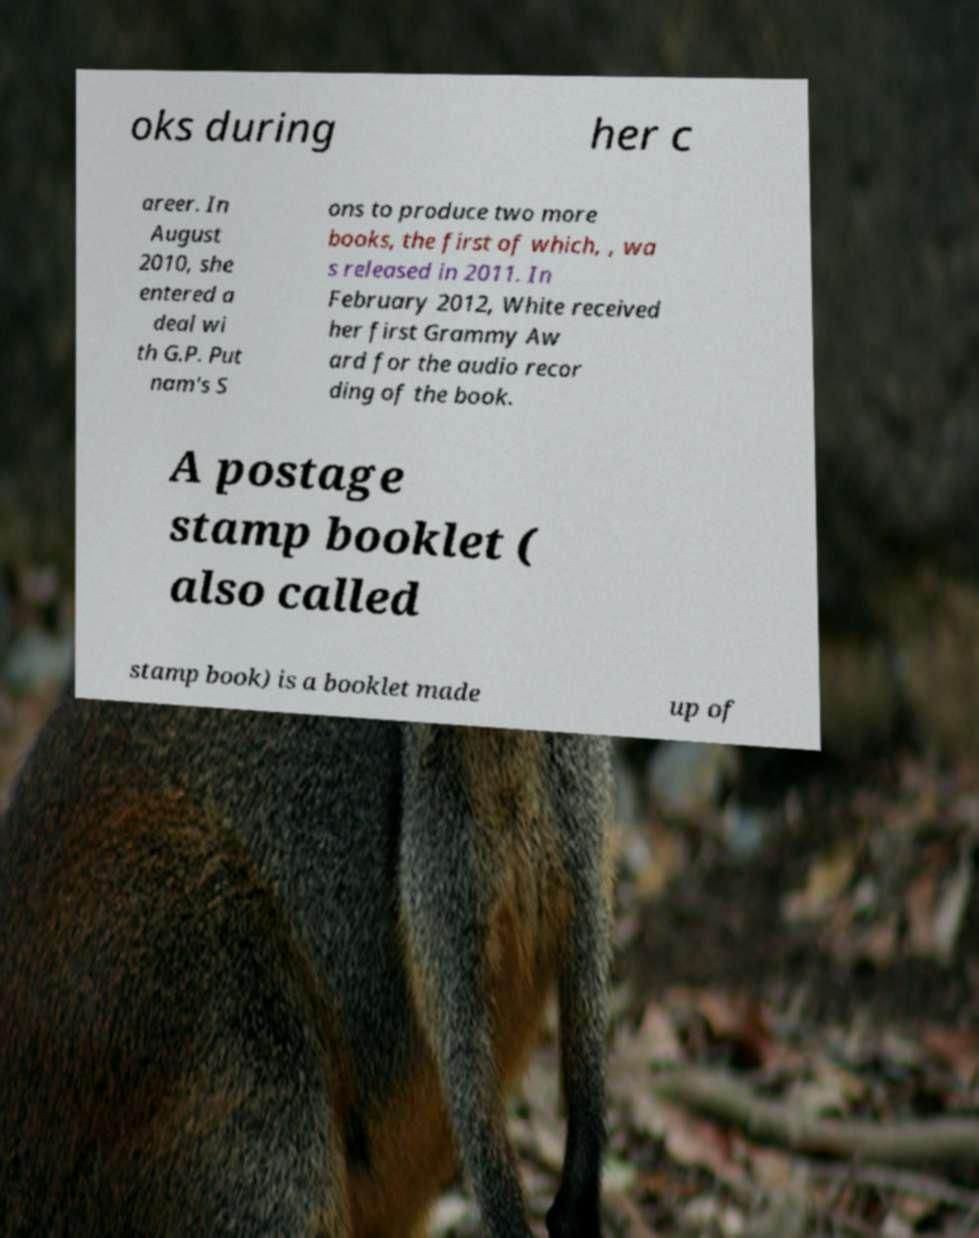What messages or text are displayed in this image? I need them in a readable, typed format. oks during her c areer. In August 2010, she entered a deal wi th G.P. Put nam's S ons to produce two more books, the first of which, , wa s released in 2011. In February 2012, White received her first Grammy Aw ard for the audio recor ding of the book. A postage stamp booklet ( also called stamp book) is a booklet made up of 